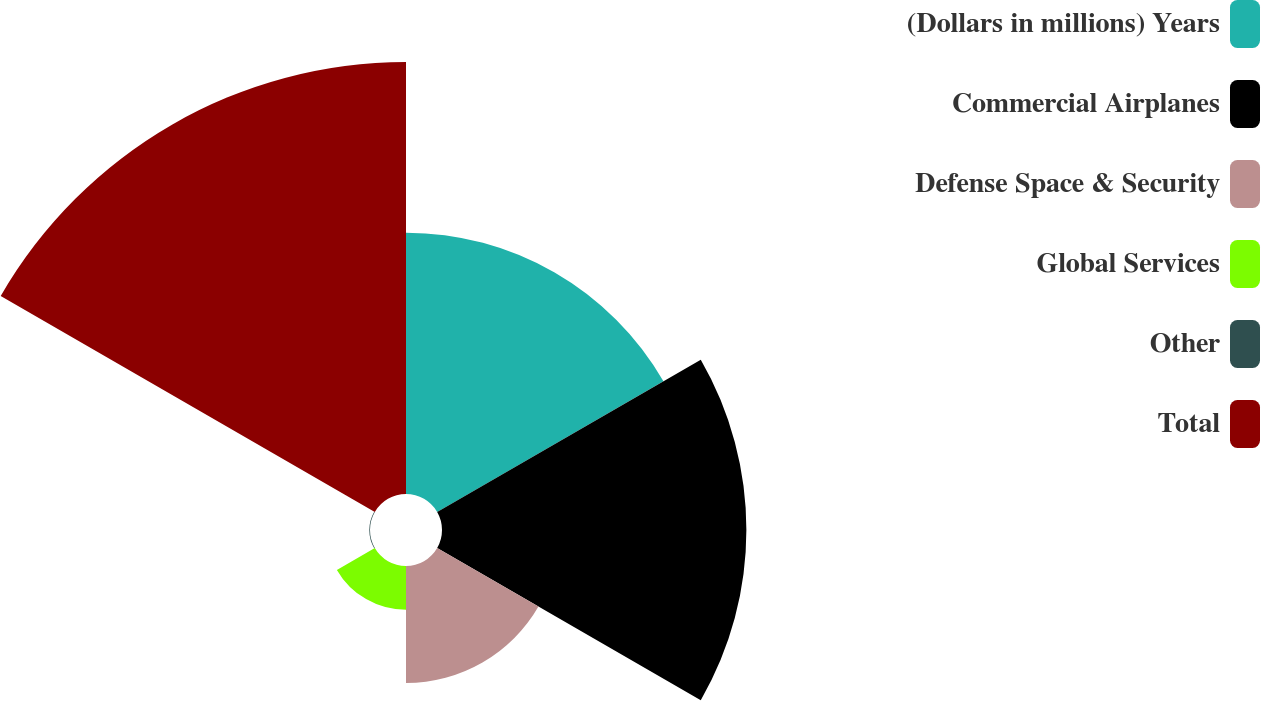Convert chart to OTSL. <chart><loc_0><loc_0><loc_500><loc_500><pie_chart><fcel>(Dollars in millions) Years<fcel>Commercial Airplanes<fcel>Defense Space & Security<fcel>Global Services<fcel>Other<fcel>Total<nl><fcel>22.54%<fcel>26.26%<fcel>10.09%<fcel>3.78%<fcel>0.06%<fcel>37.27%<nl></chart> 